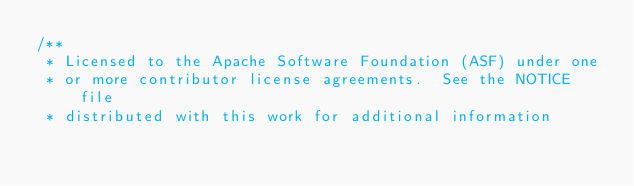Convert code to text. <code><loc_0><loc_0><loc_500><loc_500><_Java_>/**
 * Licensed to the Apache Software Foundation (ASF) under one
 * or more contributor license agreements.  See the NOTICE file
 * distributed with this work for additional information</code> 